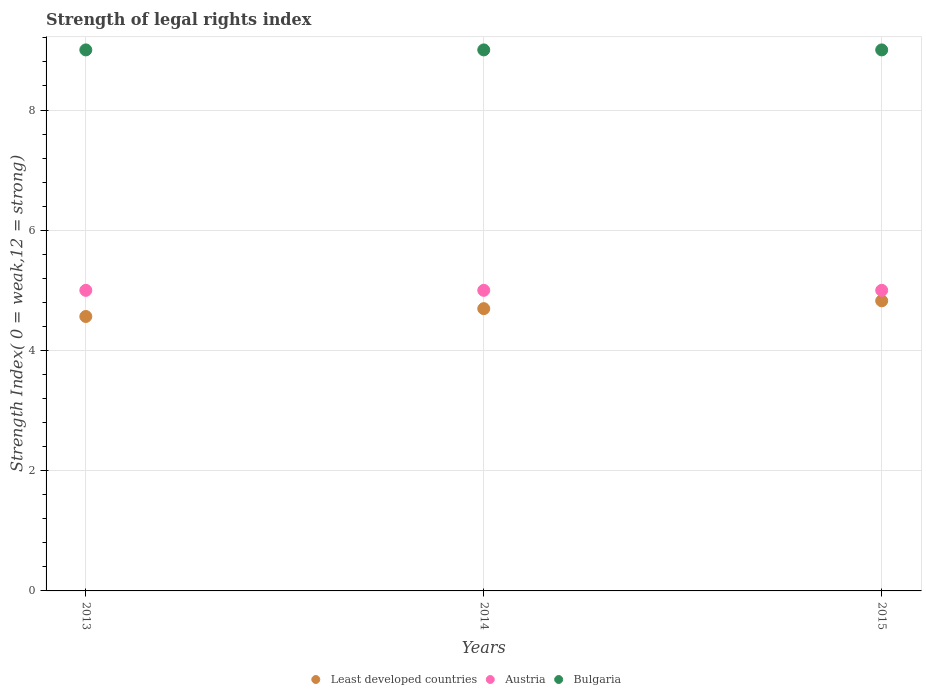Is the number of dotlines equal to the number of legend labels?
Provide a succinct answer. Yes. What is the strength index in Austria in 2014?
Ensure brevity in your answer.  5. Across all years, what is the maximum strength index in Austria?
Your answer should be compact. 5. Across all years, what is the minimum strength index in Bulgaria?
Your answer should be very brief. 9. In which year was the strength index in Austria minimum?
Your answer should be very brief. 2013. What is the total strength index in Austria in the graph?
Your response must be concise. 15. What is the difference between the strength index in Least developed countries in 2013 and that in 2014?
Provide a succinct answer. -0.13. What is the difference between the strength index in Bulgaria in 2013 and the strength index in Austria in 2014?
Offer a very short reply. 4. What is the average strength index in Least developed countries per year?
Provide a succinct answer. 4.7. In the year 2013, what is the difference between the strength index in Bulgaria and strength index in Least developed countries?
Keep it short and to the point. 4.43. What is the ratio of the strength index in Bulgaria in 2013 to that in 2015?
Offer a terse response. 1. What is the difference between the highest and the second highest strength index in Bulgaria?
Provide a succinct answer. 0. What is the difference between the highest and the lowest strength index in Least developed countries?
Your answer should be compact. 0.26. In how many years, is the strength index in Austria greater than the average strength index in Austria taken over all years?
Ensure brevity in your answer.  0. Is the strength index in Austria strictly less than the strength index in Least developed countries over the years?
Your answer should be compact. No. How many years are there in the graph?
Offer a terse response. 3. What is the difference between two consecutive major ticks on the Y-axis?
Give a very brief answer. 2. Are the values on the major ticks of Y-axis written in scientific E-notation?
Give a very brief answer. No. Does the graph contain any zero values?
Keep it short and to the point. No. How are the legend labels stacked?
Give a very brief answer. Horizontal. What is the title of the graph?
Your response must be concise. Strength of legal rights index. What is the label or title of the Y-axis?
Offer a very short reply. Strength Index( 0 = weak,12 = strong). What is the Strength Index( 0 = weak,12 = strong) of Least developed countries in 2013?
Provide a short and direct response. 4.57. What is the Strength Index( 0 = weak,12 = strong) of Austria in 2013?
Provide a succinct answer. 5. What is the Strength Index( 0 = weak,12 = strong) in Least developed countries in 2014?
Give a very brief answer. 4.7. What is the Strength Index( 0 = weak,12 = strong) of Austria in 2014?
Make the answer very short. 5. What is the Strength Index( 0 = weak,12 = strong) in Bulgaria in 2014?
Provide a short and direct response. 9. What is the Strength Index( 0 = weak,12 = strong) in Least developed countries in 2015?
Offer a very short reply. 4.83. Across all years, what is the maximum Strength Index( 0 = weak,12 = strong) of Least developed countries?
Make the answer very short. 4.83. Across all years, what is the minimum Strength Index( 0 = weak,12 = strong) of Least developed countries?
Make the answer very short. 4.57. What is the total Strength Index( 0 = weak,12 = strong) in Least developed countries in the graph?
Provide a succinct answer. 14.09. What is the total Strength Index( 0 = weak,12 = strong) of Bulgaria in the graph?
Provide a succinct answer. 27. What is the difference between the Strength Index( 0 = weak,12 = strong) in Least developed countries in 2013 and that in 2014?
Your answer should be very brief. -0.13. What is the difference between the Strength Index( 0 = weak,12 = strong) of Austria in 2013 and that in 2014?
Keep it short and to the point. 0. What is the difference between the Strength Index( 0 = weak,12 = strong) of Least developed countries in 2013 and that in 2015?
Provide a short and direct response. -0.26. What is the difference between the Strength Index( 0 = weak,12 = strong) of Least developed countries in 2014 and that in 2015?
Make the answer very short. -0.13. What is the difference between the Strength Index( 0 = weak,12 = strong) of Austria in 2014 and that in 2015?
Provide a short and direct response. 0. What is the difference between the Strength Index( 0 = weak,12 = strong) in Least developed countries in 2013 and the Strength Index( 0 = weak,12 = strong) in Austria in 2014?
Provide a short and direct response. -0.43. What is the difference between the Strength Index( 0 = weak,12 = strong) of Least developed countries in 2013 and the Strength Index( 0 = weak,12 = strong) of Bulgaria in 2014?
Give a very brief answer. -4.43. What is the difference between the Strength Index( 0 = weak,12 = strong) in Austria in 2013 and the Strength Index( 0 = weak,12 = strong) in Bulgaria in 2014?
Offer a very short reply. -4. What is the difference between the Strength Index( 0 = weak,12 = strong) in Least developed countries in 2013 and the Strength Index( 0 = weak,12 = strong) in Austria in 2015?
Give a very brief answer. -0.43. What is the difference between the Strength Index( 0 = weak,12 = strong) in Least developed countries in 2013 and the Strength Index( 0 = weak,12 = strong) in Bulgaria in 2015?
Give a very brief answer. -4.43. What is the difference between the Strength Index( 0 = weak,12 = strong) in Austria in 2013 and the Strength Index( 0 = weak,12 = strong) in Bulgaria in 2015?
Provide a short and direct response. -4. What is the difference between the Strength Index( 0 = weak,12 = strong) of Least developed countries in 2014 and the Strength Index( 0 = weak,12 = strong) of Austria in 2015?
Your answer should be very brief. -0.3. What is the difference between the Strength Index( 0 = weak,12 = strong) of Least developed countries in 2014 and the Strength Index( 0 = weak,12 = strong) of Bulgaria in 2015?
Ensure brevity in your answer.  -4.3. What is the difference between the Strength Index( 0 = weak,12 = strong) in Austria in 2014 and the Strength Index( 0 = weak,12 = strong) in Bulgaria in 2015?
Ensure brevity in your answer.  -4. What is the average Strength Index( 0 = weak,12 = strong) of Least developed countries per year?
Offer a terse response. 4.7. What is the average Strength Index( 0 = weak,12 = strong) of Bulgaria per year?
Offer a very short reply. 9. In the year 2013, what is the difference between the Strength Index( 0 = weak,12 = strong) of Least developed countries and Strength Index( 0 = weak,12 = strong) of Austria?
Make the answer very short. -0.43. In the year 2013, what is the difference between the Strength Index( 0 = weak,12 = strong) of Least developed countries and Strength Index( 0 = weak,12 = strong) of Bulgaria?
Your answer should be very brief. -4.43. In the year 2014, what is the difference between the Strength Index( 0 = weak,12 = strong) in Least developed countries and Strength Index( 0 = weak,12 = strong) in Austria?
Provide a short and direct response. -0.3. In the year 2014, what is the difference between the Strength Index( 0 = weak,12 = strong) in Least developed countries and Strength Index( 0 = weak,12 = strong) in Bulgaria?
Your answer should be compact. -4.3. In the year 2014, what is the difference between the Strength Index( 0 = weak,12 = strong) of Austria and Strength Index( 0 = weak,12 = strong) of Bulgaria?
Offer a terse response. -4. In the year 2015, what is the difference between the Strength Index( 0 = weak,12 = strong) of Least developed countries and Strength Index( 0 = weak,12 = strong) of Austria?
Offer a very short reply. -0.17. In the year 2015, what is the difference between the Strength Index( 0 = weak,12 = strong) in Least developed countries and Strength Index( 0 = weak,12 = strong) in Bulgaria?
Offer a terse response. -4.17. What is the ratio of the Strength Index( 0 = weak,12 = strong) of Least developed countries in 2013 to that in 2014?
Your response must be concise. 0.97. What is the ratio of the Strength Index( 0 = weak,12 = strong) in Least developed countries in 2013 to that in 2015?
Offer a very short reply. 0.95. What is the ratio of the Strength Index( 0 = weak,12 = strong) of Least developed countries in 2014 to that in 2015?
Your answer should be very brief. 0.97. What is the ratio of the Strength Index( 0 = weak,12 = strong) in Bulgaria in 2014 to that in 2015?
Offer a very short reply. 1. What is the difference between the highest and the second highest Strength Index( 0 = weak,12 = strong) in Least developed countries?
Give a very brief answer. 0.13. What is the difference between the highest and the lowest Strength Index( 0 = weak,12 = strong) of Least developed countries?
Your answer should be compact. 0.26. What is the difference between the highest and the lowest Strength Index( 0 = weak,12 = strong) of Bulgaria?
Your response must be concise. 0. 